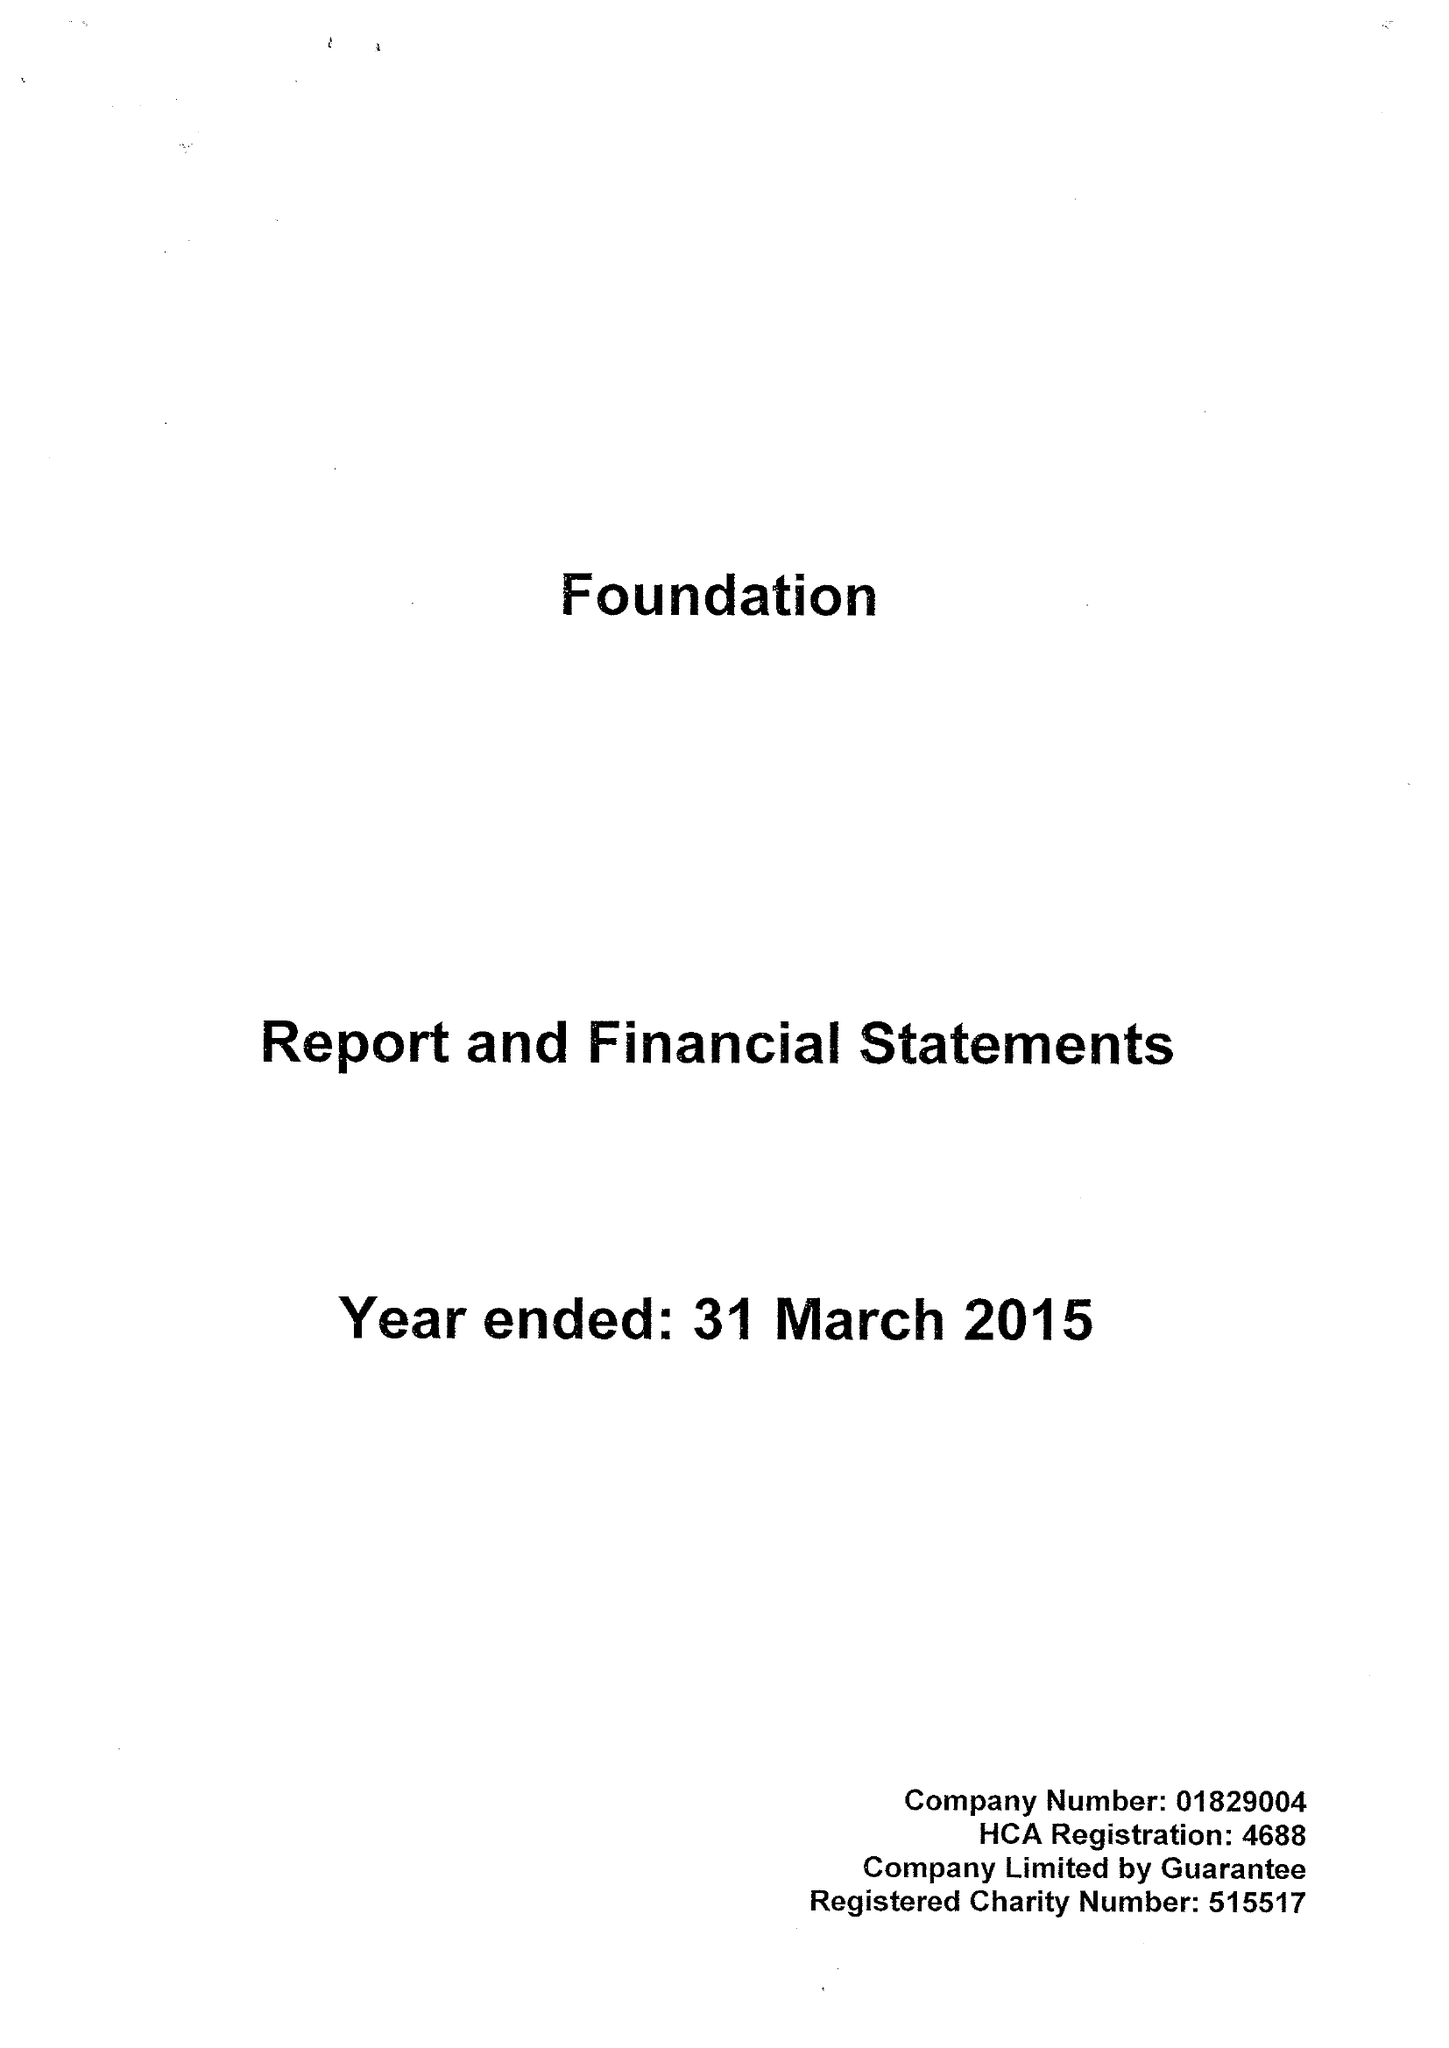What is the value for the charity_number?
Answer the question using a single word or phrase. 515517 